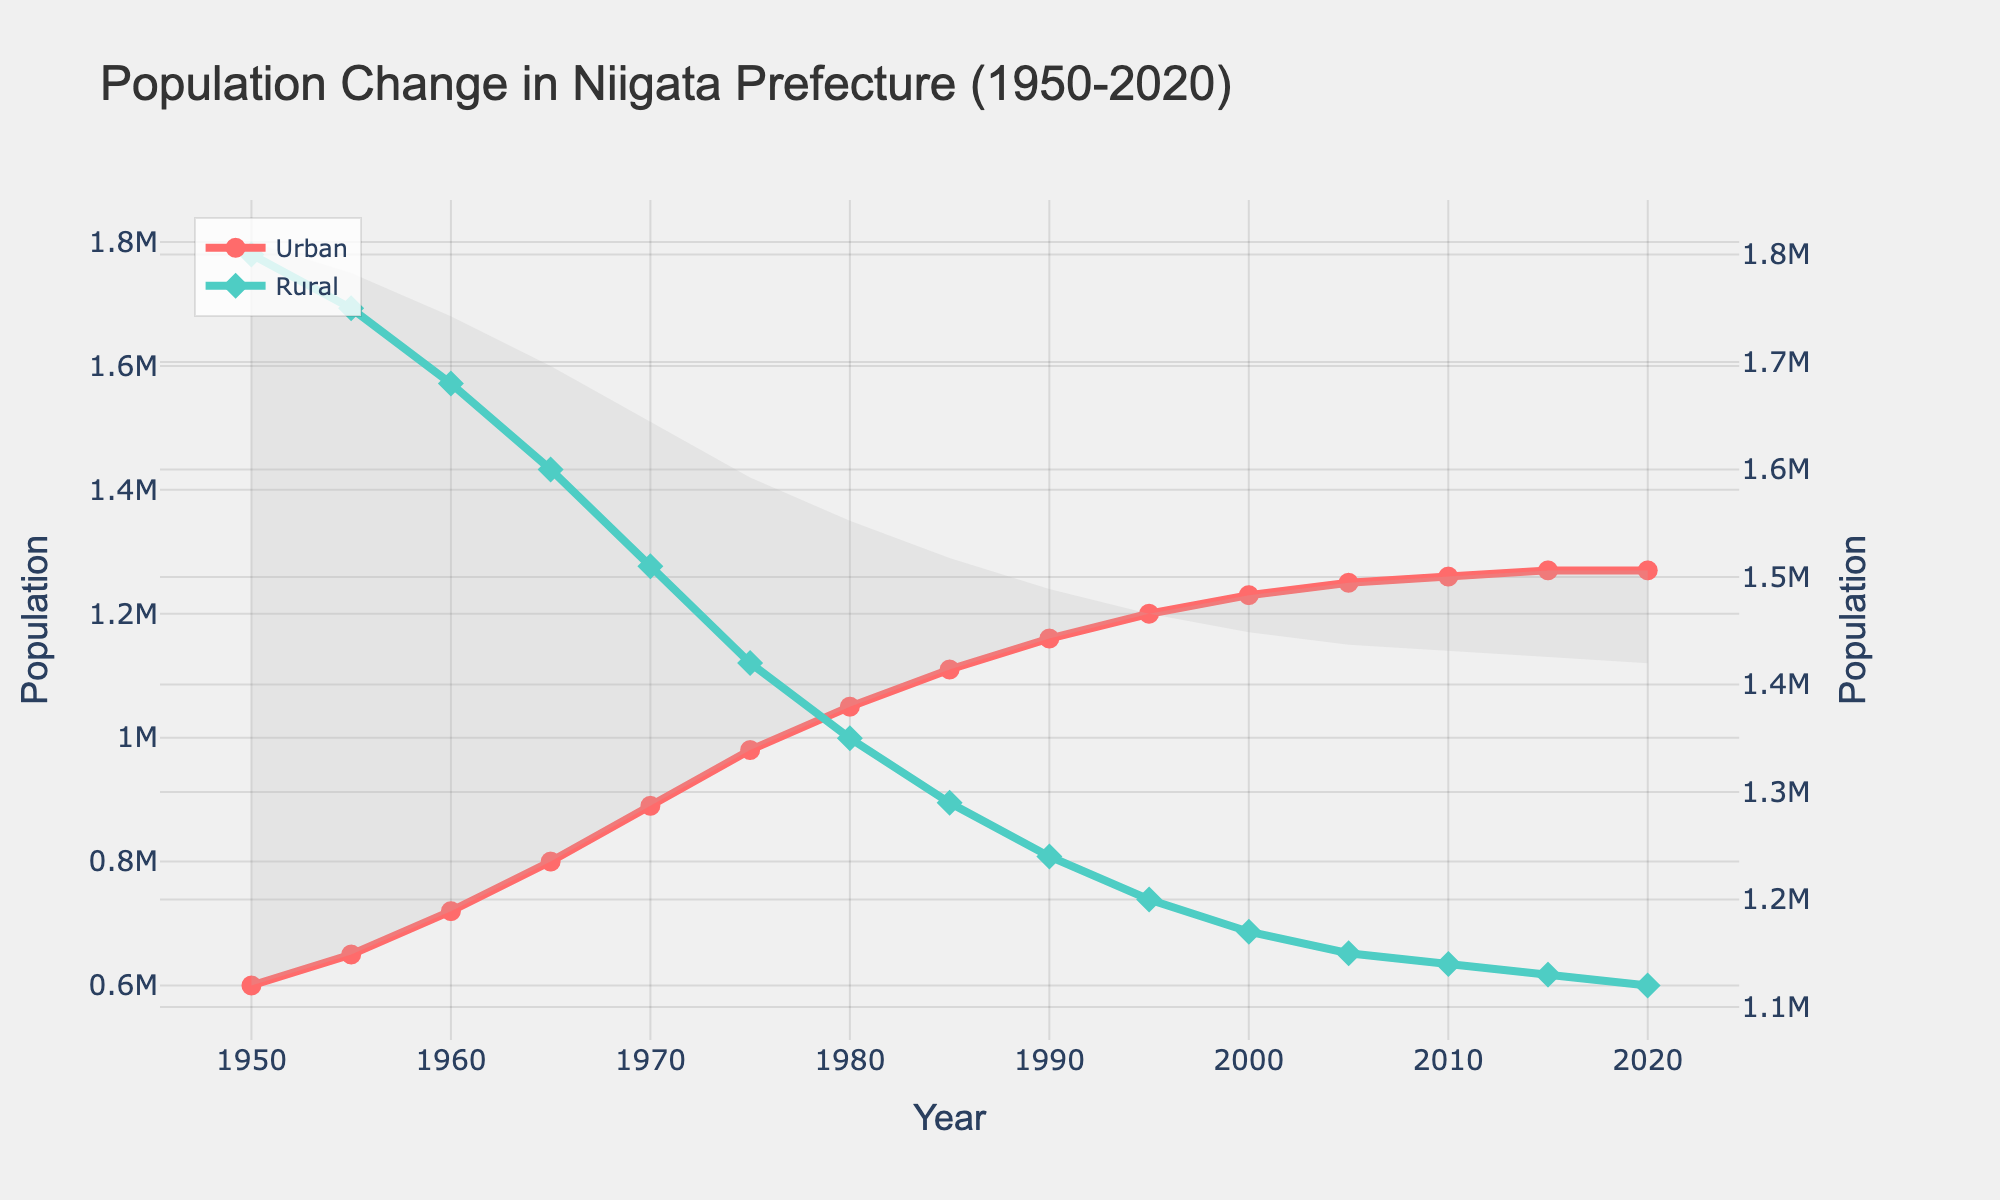What year did the urban population first surpass 1 million? From the visual attributes, we observe that the urban population line crosses the 1 million mark between the years 1975 and 1980. By checking the data points more closely, we see that in 1980, the urban population reached 1,050,000.
Answer: 1980 How much did the rural population decrease from 1950 to 2020? The rural population in 1950 was 1,800,000, and in 2020 it was 1,120,000. The decrease in the rural population can be calculated as 1,800,000 - 1,120,000. 1,800,000 - 1,120,000 = 680,000
Answer: 680,000 In which decade did the urban population see the highest growth? By observing the increments on the urban population line, the highest growth appears between 1960 and 1970, from 720,000 to 890,000. The growth is 890,000 - 720,000. 890,000 - 720,000 = 170,000
Answer: 1960-1970 What is the difference between the urban and rural populations in the year 2000? In 2000, the urban population was 1,230,000, and the rural population was 1,170,000. The difference can be found by 1,230,000 - 1,170,000. 1,230,000 - 1,170,000 = 60,000
Answer: 60,000 During which decade did the rural population decrease by the smallest amount? By examining the rural population values for each decade, the smallest decrease occurs between 2010 and 2020, from 1,140,000 to 1,120,000, which is a decrease of 20,000.
Answer: 2010-2020 What is the average population (urban and rural combined) of Niigata in 1980? In 1980, the urban population was 1,050,000, and the rural population was 1,350,000. The combined population is 1,050,000 + 1,350,000. The average is (1,050,000 + 1,350,000) / 2. (1,050,000 + 1,350,000) / 2 = 1,200,000
Answer: 1,200,000 Which population, urban or rural, was higher in 1990 and by how much? In 1990, the urban population was 1,160,000, and the rural population was 1,240,000. The rural population was higher by 1,240,000 - 1,160,000. 1,240,000 - 1,160,000 = 80,000
Answer: Rural by 80,000 How many years did it take for the urban population to double from its 1950 value? In 1950, the urban population was 600,000. Doubling it would be 1,200,000. By inspecting the urban population trend, the population reaches around 1,200,000 in the year 1995. 1995 - 1950 = 45 years
Answer: 45 years 